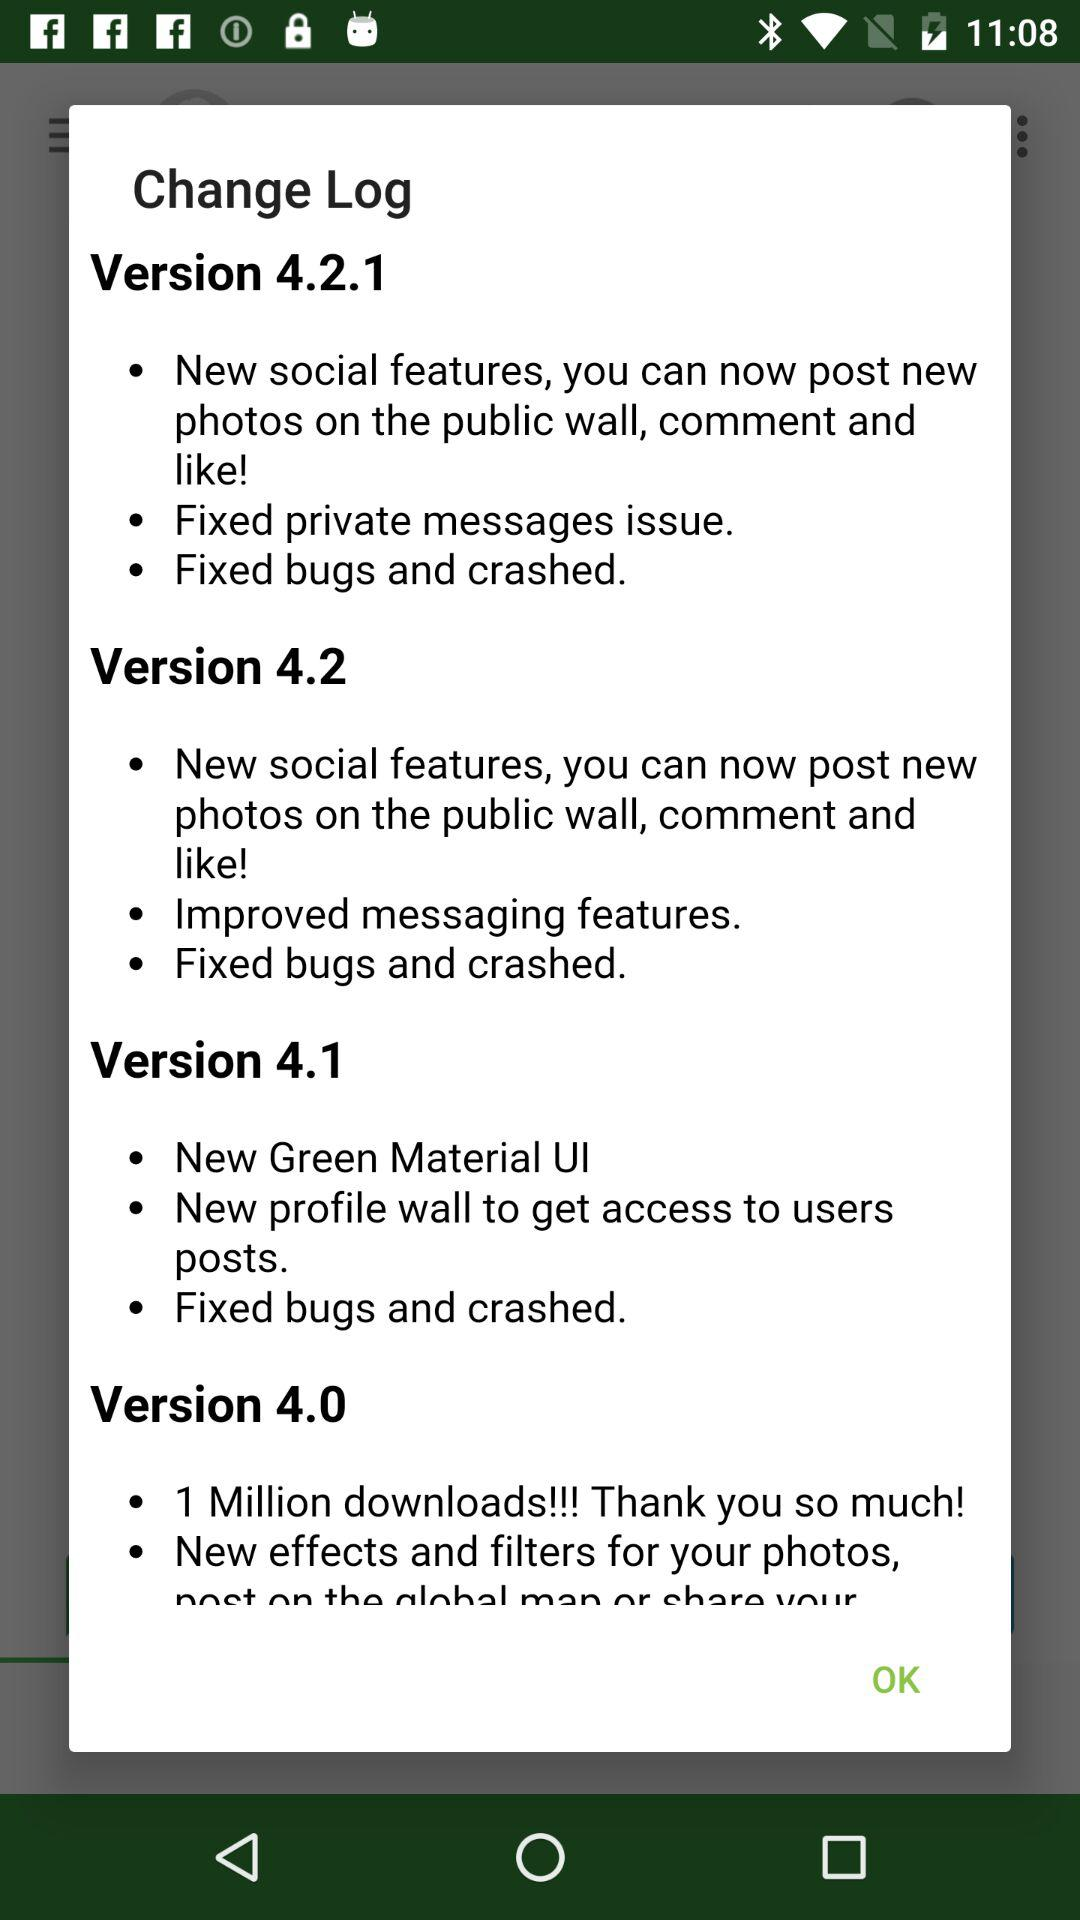How many versions have a new profile wall feature?
Answer the question using a single word or phrase. 2 